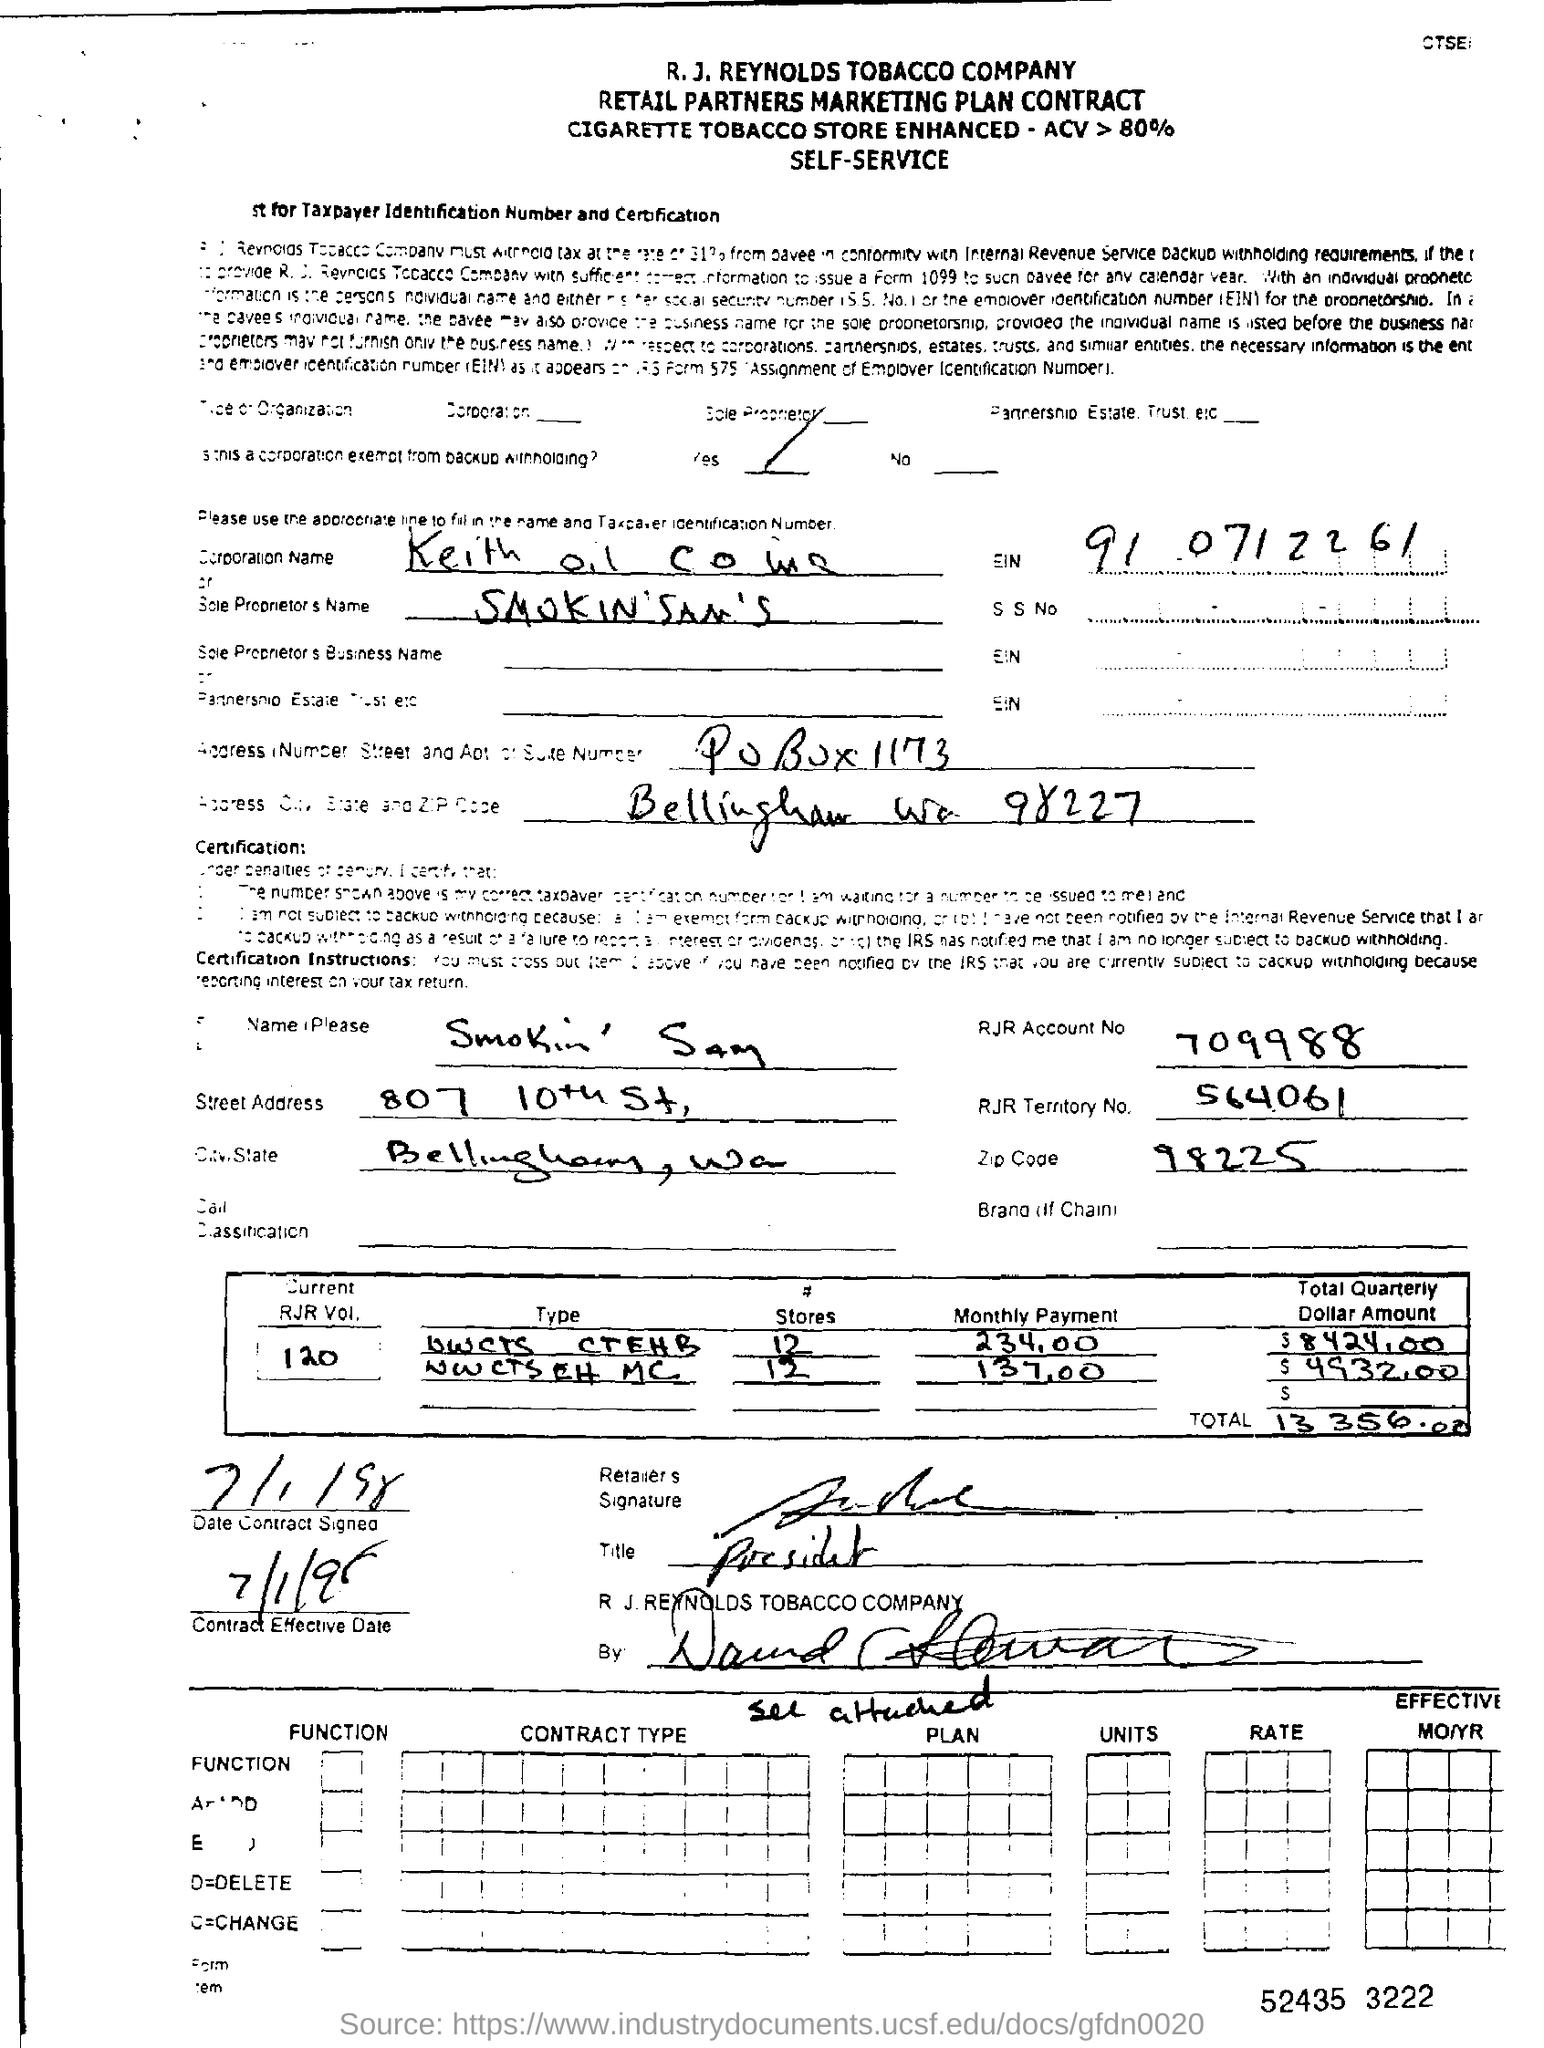What is the RJR Account No mentioned in the contract form? The RJR Account Number mentioned in the contract form is 709988, as indicated in the upper right section of the document under the header 'Smokin' Sam's'. 